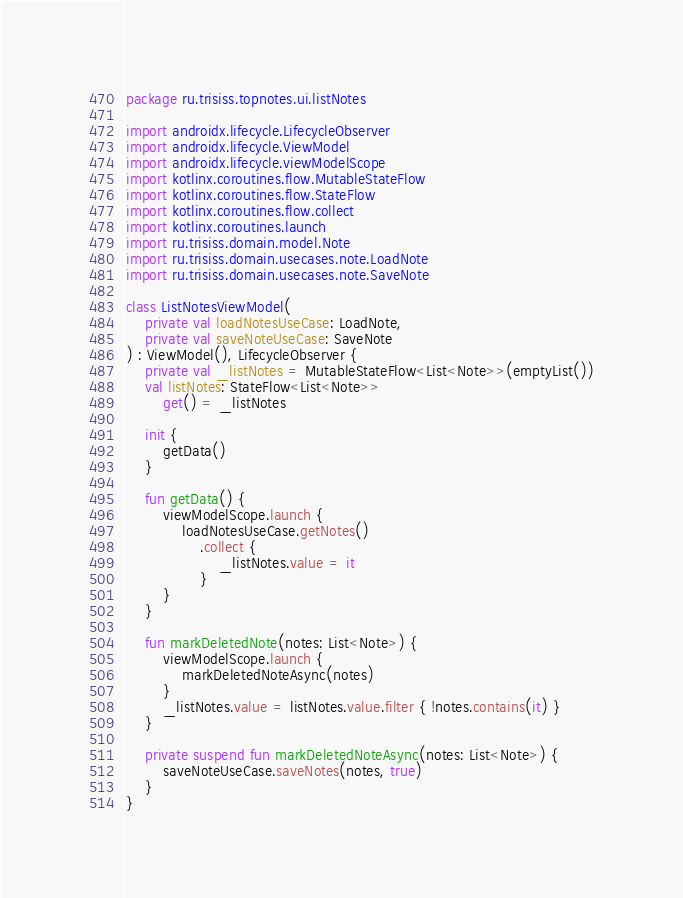<code> <loc_0><loc_0><loc_500><loc_500><_Kotlin_>package ru.trisiss.topnotes.ui.listNotes

import androidx.lifecycle.LifecycleObserver
import androidx.lifecycle.ViewModel
import androidx.lifecycle.viewModelScope
import kotlinx.coroutines.flow.MutableStateFlow
import kotlinx.coroutines.flow.StateFlow
import kotlinx.coroutines.flow.collect
import kotlinx.coroutines.launch
import ru.trisiss.domain.model.Note
import ru.trisiss.domain.usecases.note.LoadNote
import ru.trisiss.domain.usecases.note.SaveNote

class ListNotesViewModel(
    private val loadNotesUseCase: LoadNote,
    private val saveNoteUseCase: SaveNote
) : ViewModel(), LifecycleObserver {
    private val _listNotes = MutableStateFlow<List<Note>>(emptyList())
    val listNotes: StateFlow<List<Note>>
        get() = _listNotes

    init {
        getData()
    }

    fun getData() {
        viewModelScope.launch {
            loadNotesUseCase.getNotes()
                .collect {
                    _listNotes.value = it
                }
        }
    }

    fun markDeletedNote(notes: List<Note>) {
        viewModelScope.launch {
            markDeletedNoteAsync(notes)
        }
        _listNotes.value = listNotes.value.filter { !notes.contains(it) }
    }

    private suspend fun markDeletedNoteAsync(notes: List<Note>) {
        saveNoteUseCase.saveNotes(notes, true)
    }
}</code> 